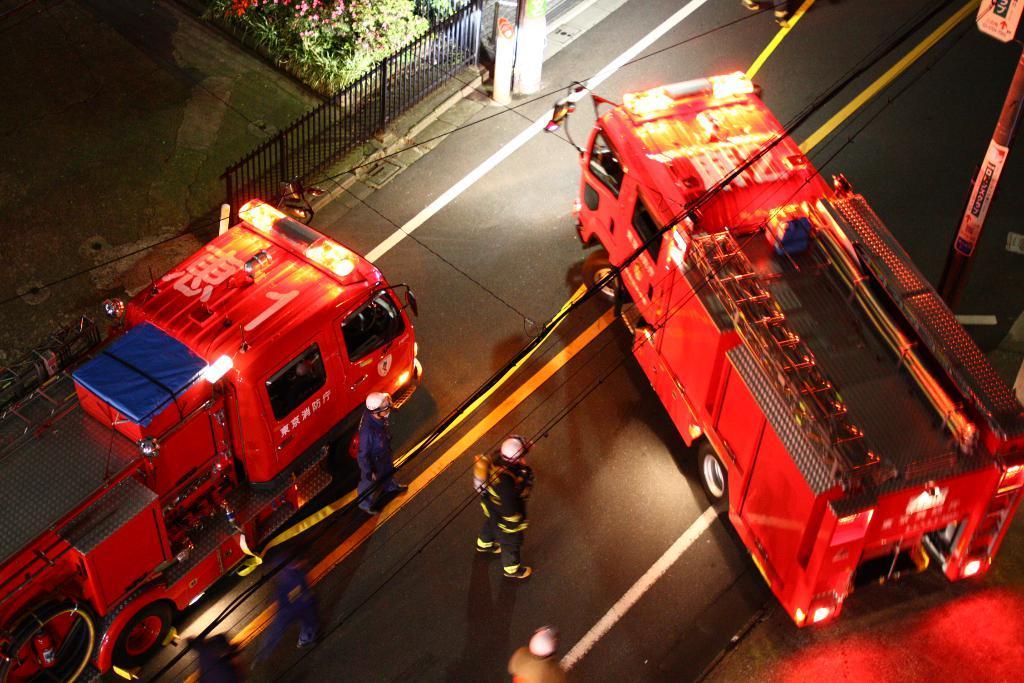Could you give a brief overview of what you see in this image? In the foreground of this image, there are fire engines on the road and also people standing and walking on the road. At the top, there are flowers, plants, railing, few poles and it seems like a board and in the right top corner. 